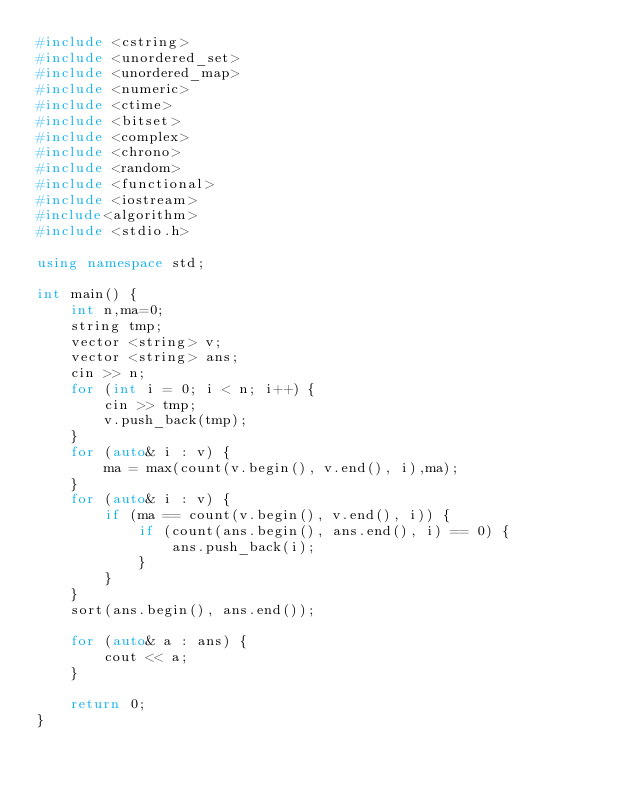<code> <loc_0><loc_0><loc_500><loc_500><_C++_>#include <cstring>
#include <unordered_set>
#include <unordered_map>
#include <numeric>
#include <ctime>
#include <bitset>
#include <complex>
#include <chrono>
#include <random>
#include <functional>
#include <iostream>
#include<algorithm>
#include <stdio.h>

using namespace std;

int main() {
	int n,ma=0;
	string tmp;
	vector <string> v;
	vector <string> ans;
	cin >> n;
	for (int i = 0; i < n; i++) {
		cin >> tmp;
		v.push_back(tmp);
	}
	for (auto& i : v) {
		ma = max(count(v.begin(), v.end(), i),ma);
	}
	for (auto& i : v) {
		if (ma == count(v.begin(), v.end(), i)) {
			if (count(ans.begin(), ans.end(), i) == 0) {
				ans.push_back(i);
			}
		}
	}
	sort(ans.begin(), ans.end());

	for (auto& a : ans) {
		cout << a;
	}
	
	return 0;
}</code> 